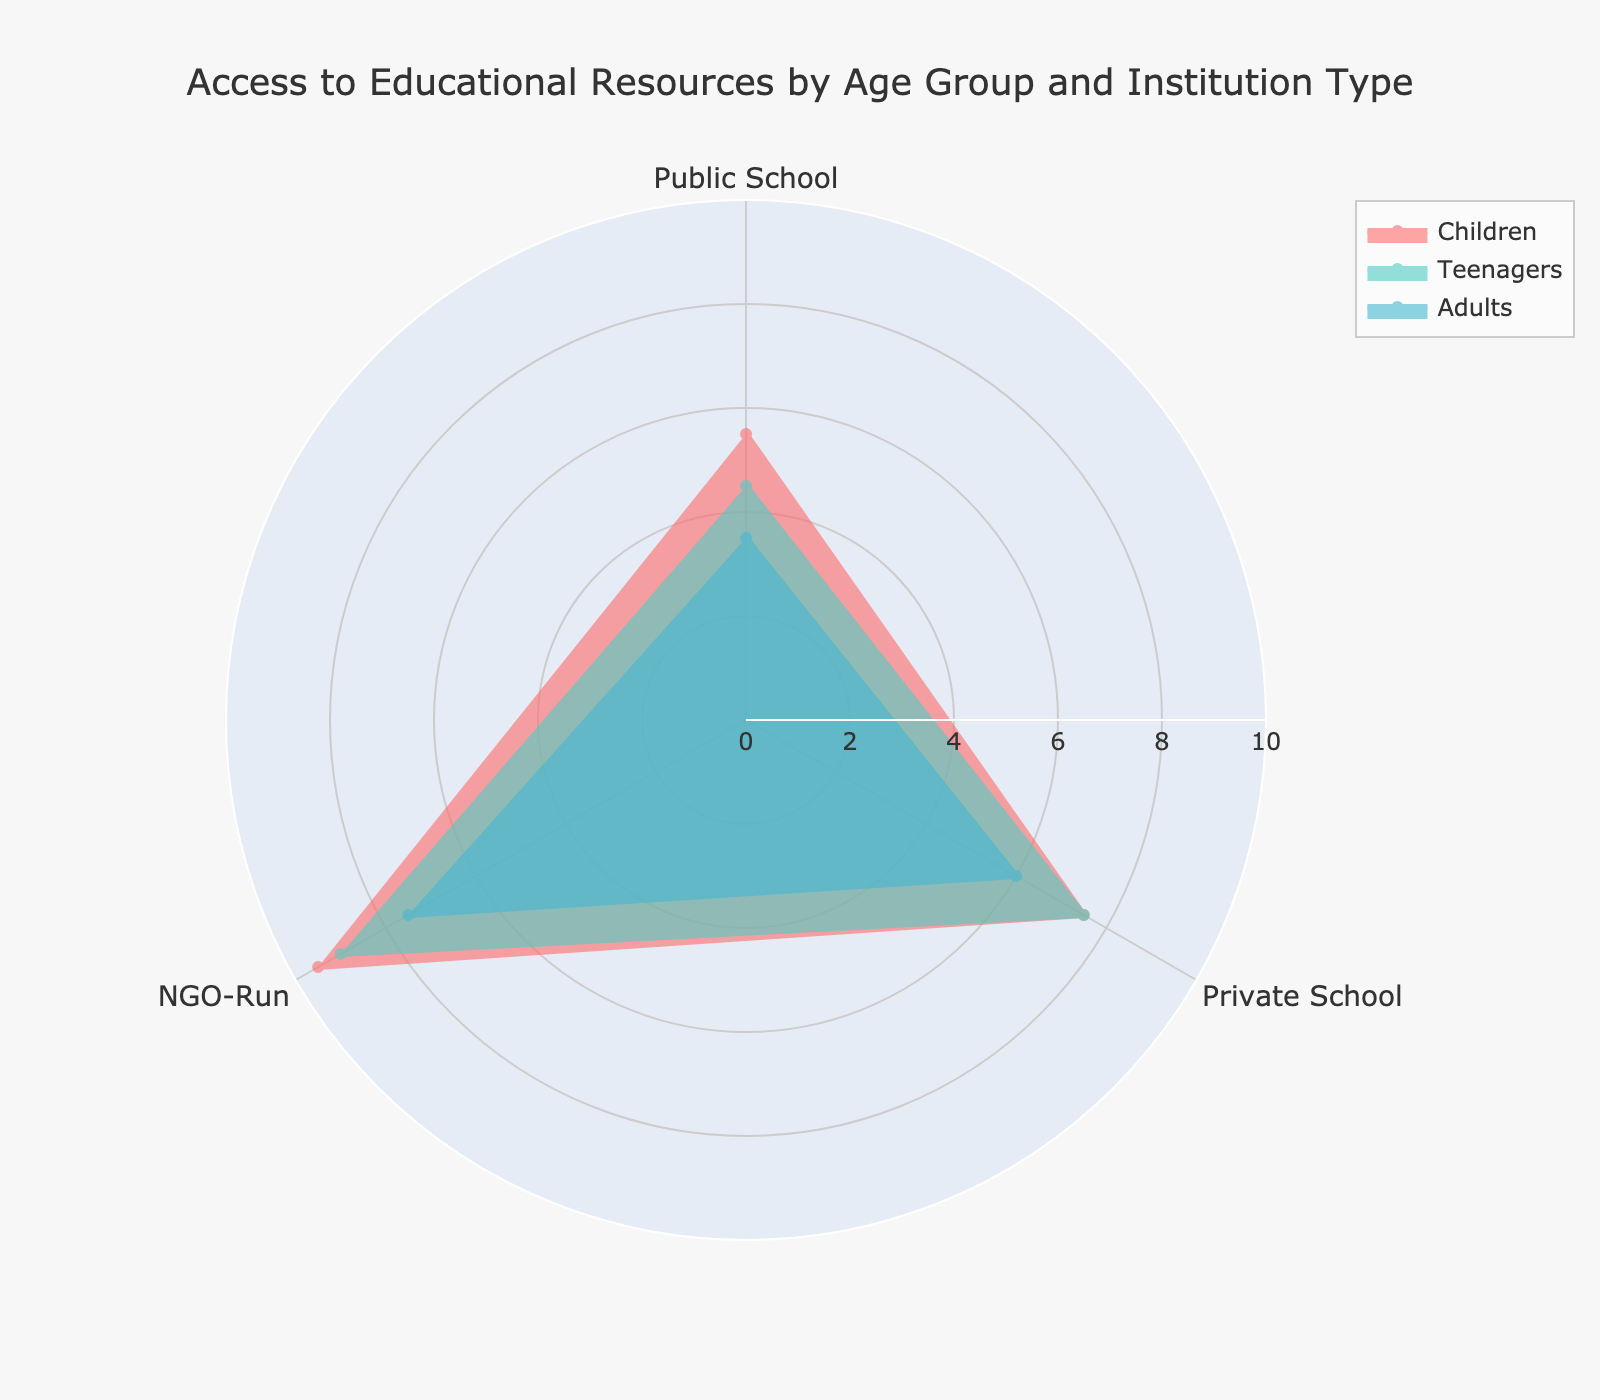What is the title of the radar chart? The title is usually located at the top of the radar chart. For this one, the title is "Access to Educational Resources by Age Group and Institution Type".
Answer: "Access to Educational Resources by Age Group and Institution Type" What are the age groups plotted in the radar chart? The age groups are generally shown as different traces in the radar chart legend. In this figure, they are "Children", "Teenagers", and "Adults".
Answer: Children, Teenagers, Adults Which institution type has the highest average access score for children? Look at the segment representing "Children" in the chart. Among the three types of institutions (Public School, Private School, NGO-Run), identify which one has the highest value. That's the NGO-Run institutions with a score of 9.5.
Answer: NGO-Run How does the access score for private schools compare between teenagers and adults? Locate the "Private School" value for both "Teenagers" and "Adults" traces. Teenagers have a score of 7.5 and adults have a score of 6. This means teenagers have better access to private school resources than adults.
Answer: Teenagers have higher scores Which gender has a better access score in NGO-Run institutions for adults? Check the separate traces for males and females under the "Adults" group for NGO-Run institutions. Females have a score of 7, while males have a score of 8.
Answer: Male What's the range of scores for public schools across all age groups? To find the range, identify the lowest and highest values for public schools across all the age groups (Children, Teenagers, Adults). The values are 3, 4, 5, and 6.
Answer: 3 to 6 Calculate the average score for teenagers across all institution types. Sum the access scores for teenagers (Public School: 4.5, Private School: 7.5, NGO-Run: 9) and divide by the number of institution types (3). The average is (4.5 + 7.5 + 9)/3 = 21/3 = 7.
Answer: 7 Which institution type shows the most significant disparity in access scores between children and adults? Compare the differences in access scores between children and adults for each institution type. The disparity for Public School is 3, for Private School is 6, and for NGO-Run is 9 - 7 = 2. The greatest difference is in Private Schools.
Answer: Private School Is access to educational resources consistently higher for one gender in NGO-Run institutions? Check the access scores for males and females across all age groups for NGO-Run institutions. Consistency means the same gender should have higher scores in each group. Females have higher scores for children (10 vs. 9), equal for teenagers (9 vs. 9), and lower for adults (7 vs. 8). Therefore, access is not consistently higher for one gender.
Answer: No 